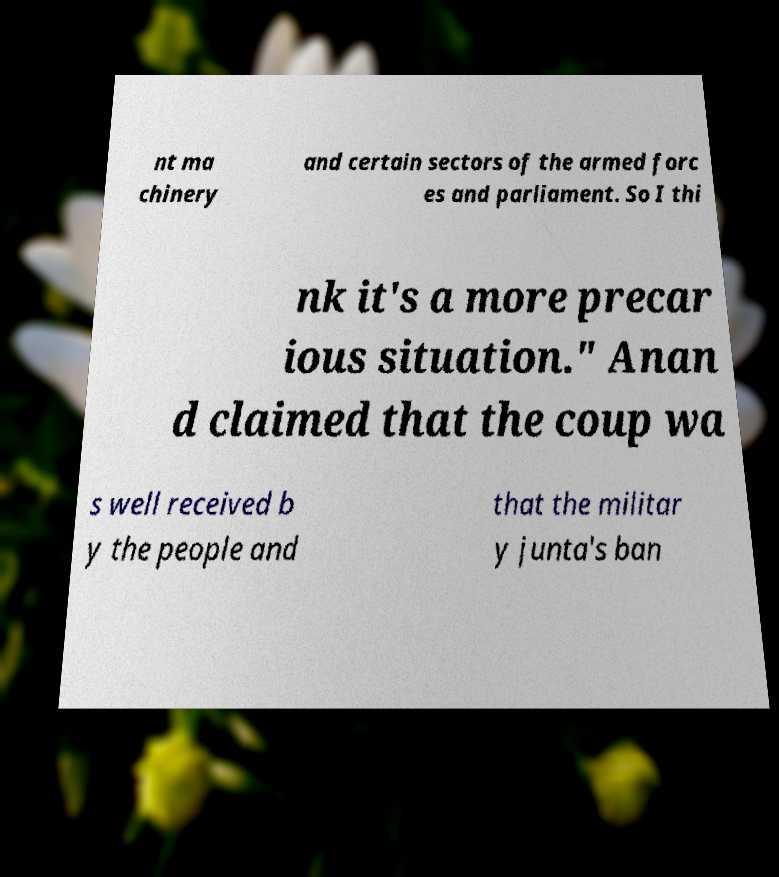Can you read and provide the text displayed in the image?This photo seems to have some interesting text. Can you extract and type it out for me? nt ma chinery and certain sectors of the armed forc es and parliament. So I thi nk it's a more precar ious situation." Anan d claimed that the coup wa s well received b y the people and that the militar y junta's ban 